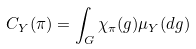Convert formula to latex. <formula><loc_0><loc_0><loc_500><loc_500>C _ { Y } ( \pi ) = \int _ { G } \chi _ { \pi } ( g ) \mu _ { Y } ( d g )</formula> 